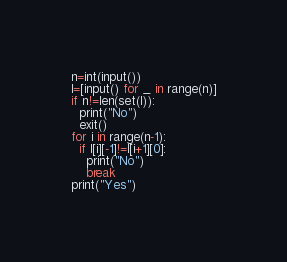<code> <loc_0><loc_0><loc_500><loc_500><_Python_>n=int(input())
l=[input() for _ in range(n)]
if n!=len(set(l)):
  print("No")
  exit()
for i in range(n-1):
  if l[i][-1]!=l[i+1][0]:
    print("No")
    break
print("Yes")
</code> 